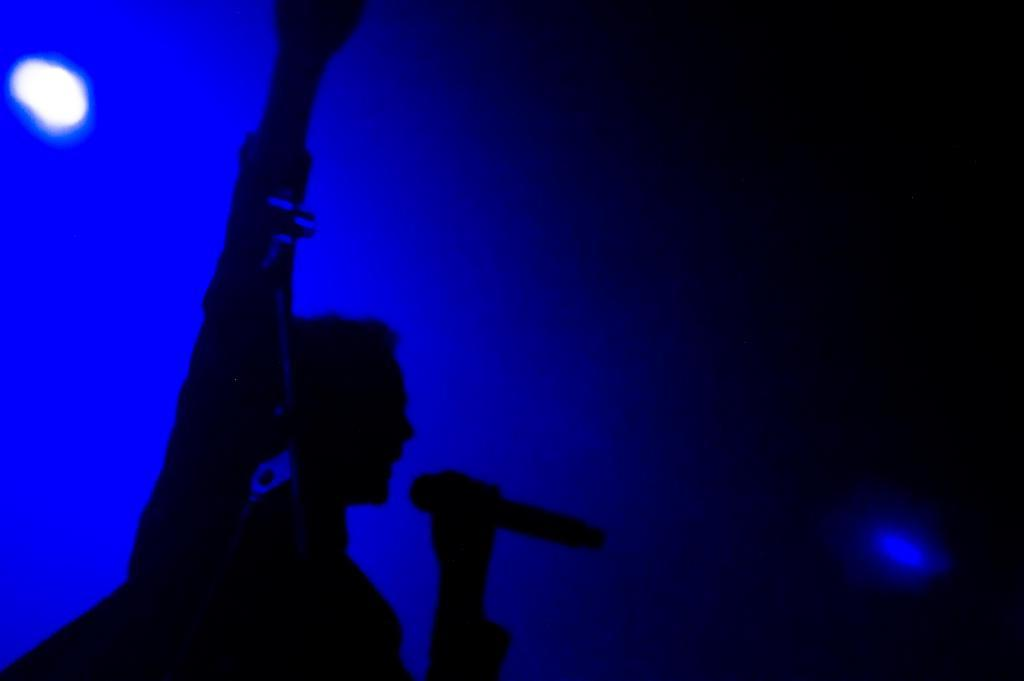What is the person in the image holding? The person is holding a mic. What action is the person performing with their hand? The person is raising their hand. What colors are predominant in the background of the image? The background is in blue and black colors. Can you see any goldfish swimming in the background of the image? There are no goldfish present in the image. What type of skirt is the person wearing in the image? The person's clothing is not described in the image, so it cannot be determined if they are wearing a skirt or any other type of clothing. 